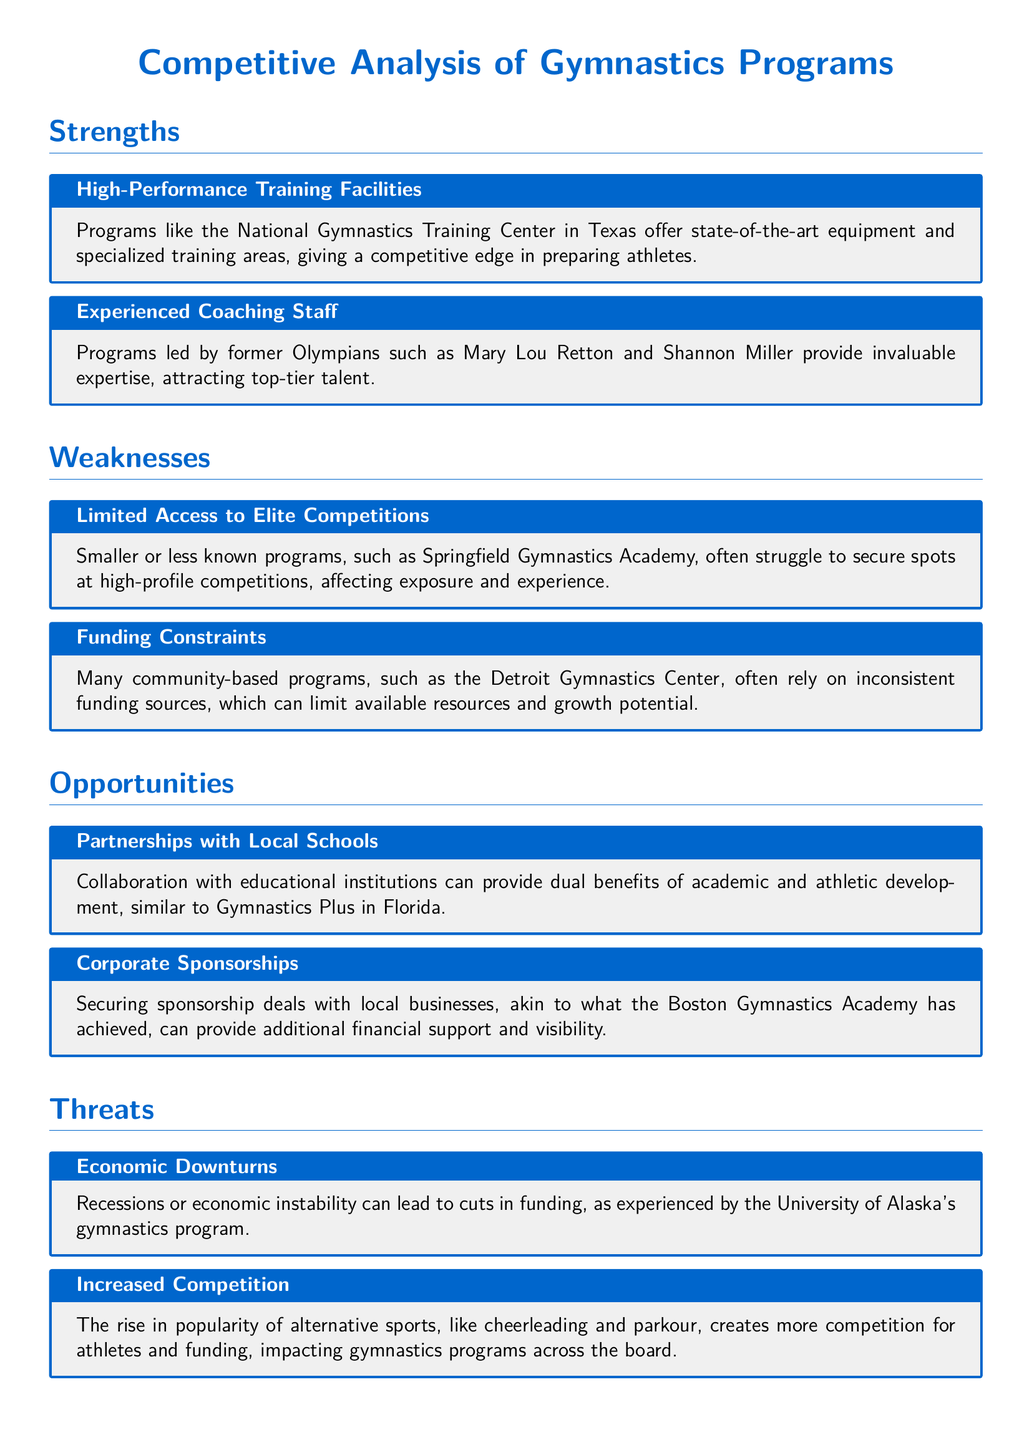What is a strength of the National Gymnastics Training Center? The National Gymnastics Training Center in Texas is known for its high-performance training facilities, providing a competitive edge.
Answer: High-Performance Training Facilities Who are some experienced coaches mentioned? The document highlights that programs are led by former Olympians, specifically naming Mary Lou Retton and Shannon Miller.
Answer: Mary Lou Retton and Shannon Miller What is a weakness experienced by smaller programs? Smaller programs like Springfield Gymnastics Academy often face limited access to elite competitions, affecting their athletes' exposure.
Answer: Limited Access to Elite Competitions What opportunity is available through local schools? Collaboration with educational institutions is mentioned as an opportunity for dual benefits in academic and athletic development.
Answer: Partnerships with Local Schools What threat affects funding for gymnastics programs? The document indicates that economic downturns can lead to cuts in funding for gymnastics programs.
Answer: Economic Downturns Which program benefits from corporate sponsorships? The Boston Gymnastics Academy has successfully secured sponsorship deals with local businesses for financial support.
Answer: Boston Gymnastics Academy What specific competition challenge is noted? Increased competition from alternative sports like cheerleading and parkour creates challenges for gymnastics programs in attracting athletes.
Answer: Increased Competition What is a common funding issue faced by community-based programs? The document states that many community-based programs rely on inconsistent funding sources, posing limits to their resources.
Answer: Funding Constraints 